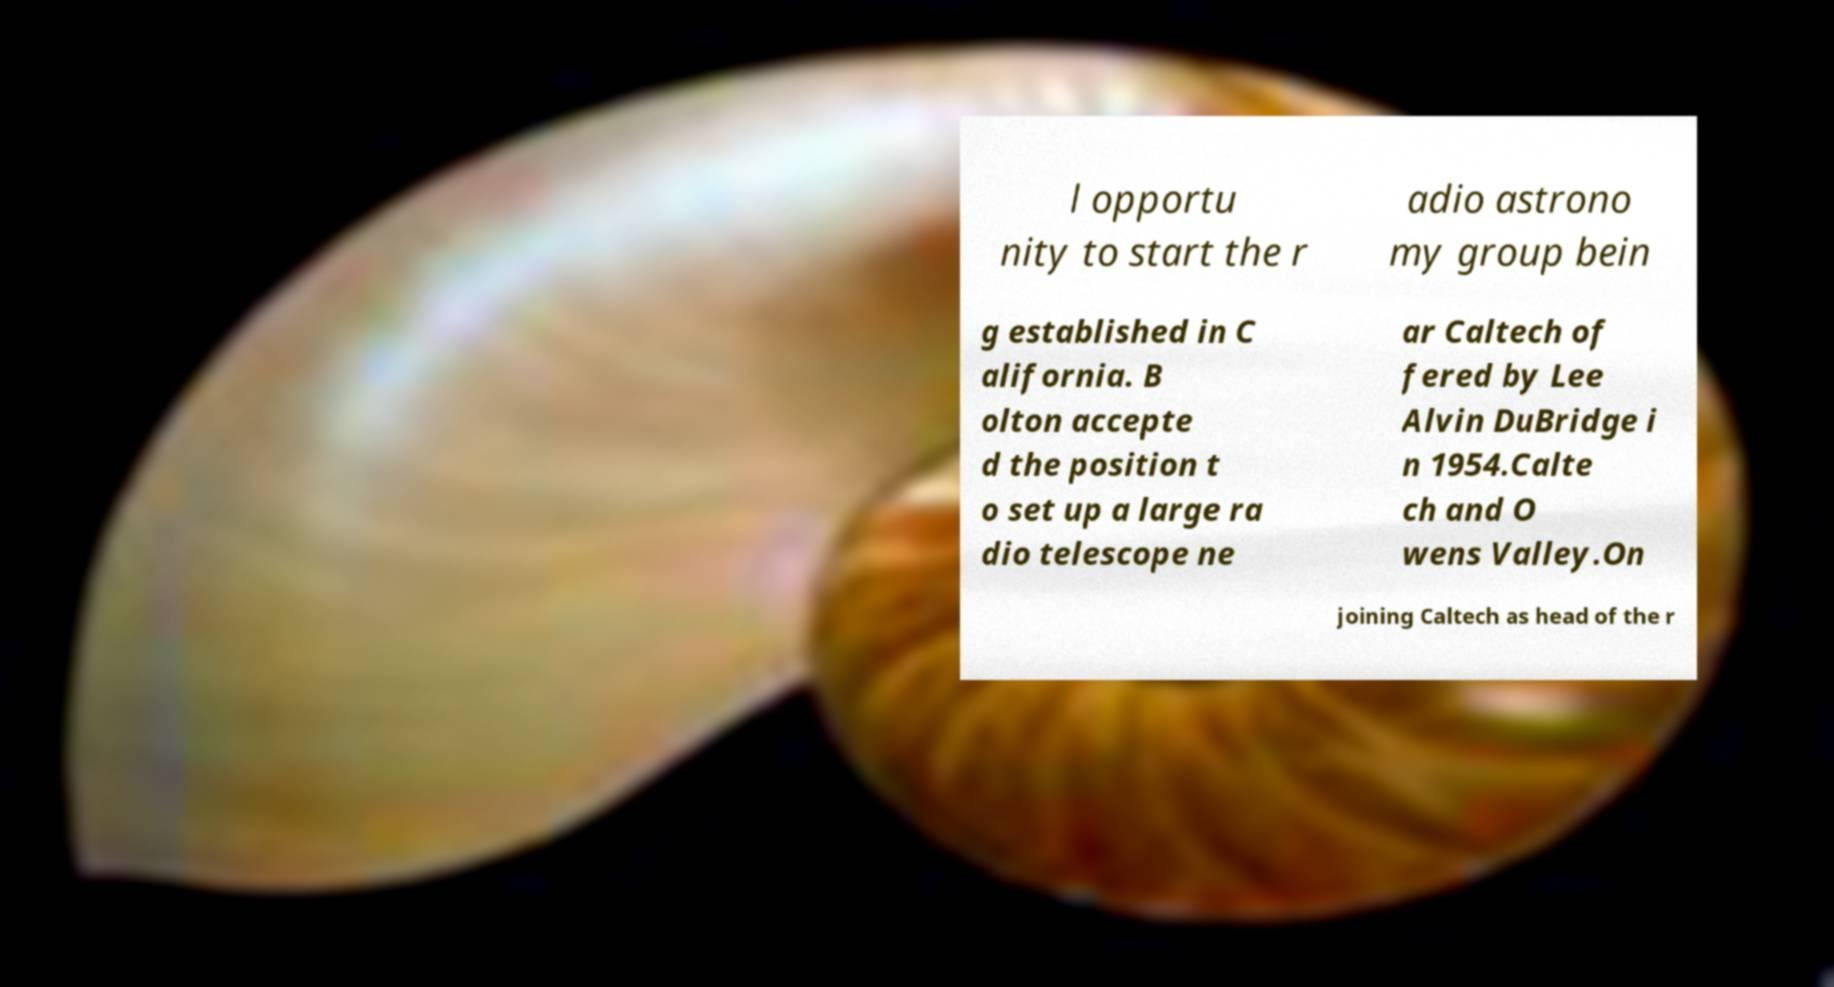Please identify and transcribe the text found in this image. l opportu nity to start the r adio astrono my group bein g established in C alifornia. B olton accepte d the position t o set up a large ra dio telescope ne ar Caltech of fered by Lee Alvin DuBridge i n 1954.Calte ch and O wens Valley.On joining Caltech as head of the r 